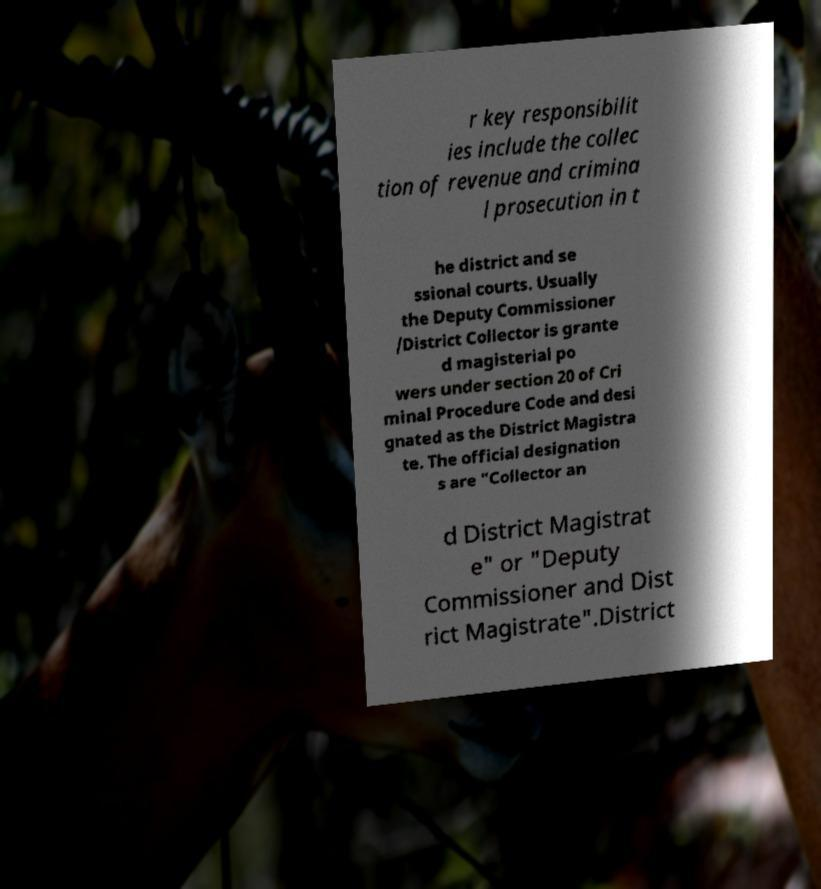I need the written content from this picture converted into text. Can you do that? r key responsibilit ies include the collec tion of revenue and crimina l prosecution in t he district and se ssional courts. Usually the Deputy Commissioner /District Collector is grante d magisterial po wers under section 20 of Cri minal Procedure Code and desi gnated as the District Magistra te. The official designation s are "Collector an d District Magistrat e" or "Deputy Commissioner and Dist rict Magistrate".District 